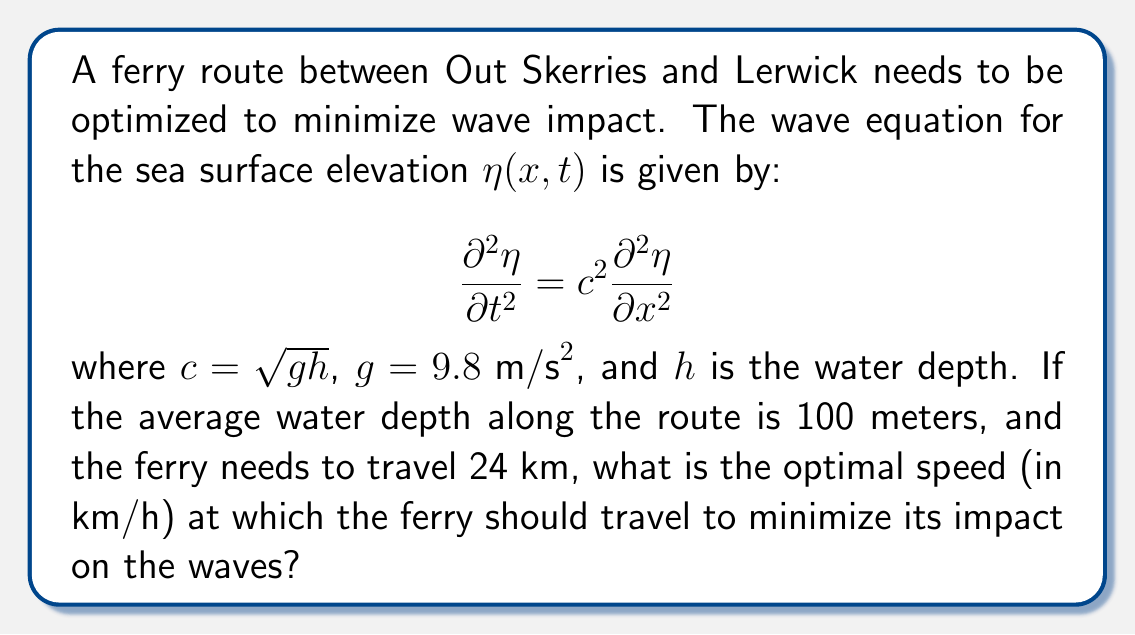Give your solution to this math problem. To solve this problem, we need to follow these steps:

1) First, calculate the wave speed $c$:
   $c = \sqrt{gh} = \sqrt{9.8 \cdot 100} = 31.3 m/s$

2) The optimal speed to minimize wave impact is when the ferry's speed matches the wave speed. This is because at this speed, the ferry will "surf" on a single wave, minimizing its overall impact on the water surface.

3) Convert the wave speed from m/s to km/h:
   $31.3 m/s \cdot \frac{3600 s}{1 h} \cdot \frac{1 km}{1000 m} = 112.68 km/h$

4) Round to the nearest whole number for practical purposes.

Therefore, the optimal speed for the ferry is approximately 113 km/h.

Note: In practice, this speed might be too high for safe ferry operation. In reality, ferries would typically operate at lower speeds, and other factors such as fuel efficiency and passenger comfort would also be considered in route optimization.
Answer: 113 km/h 